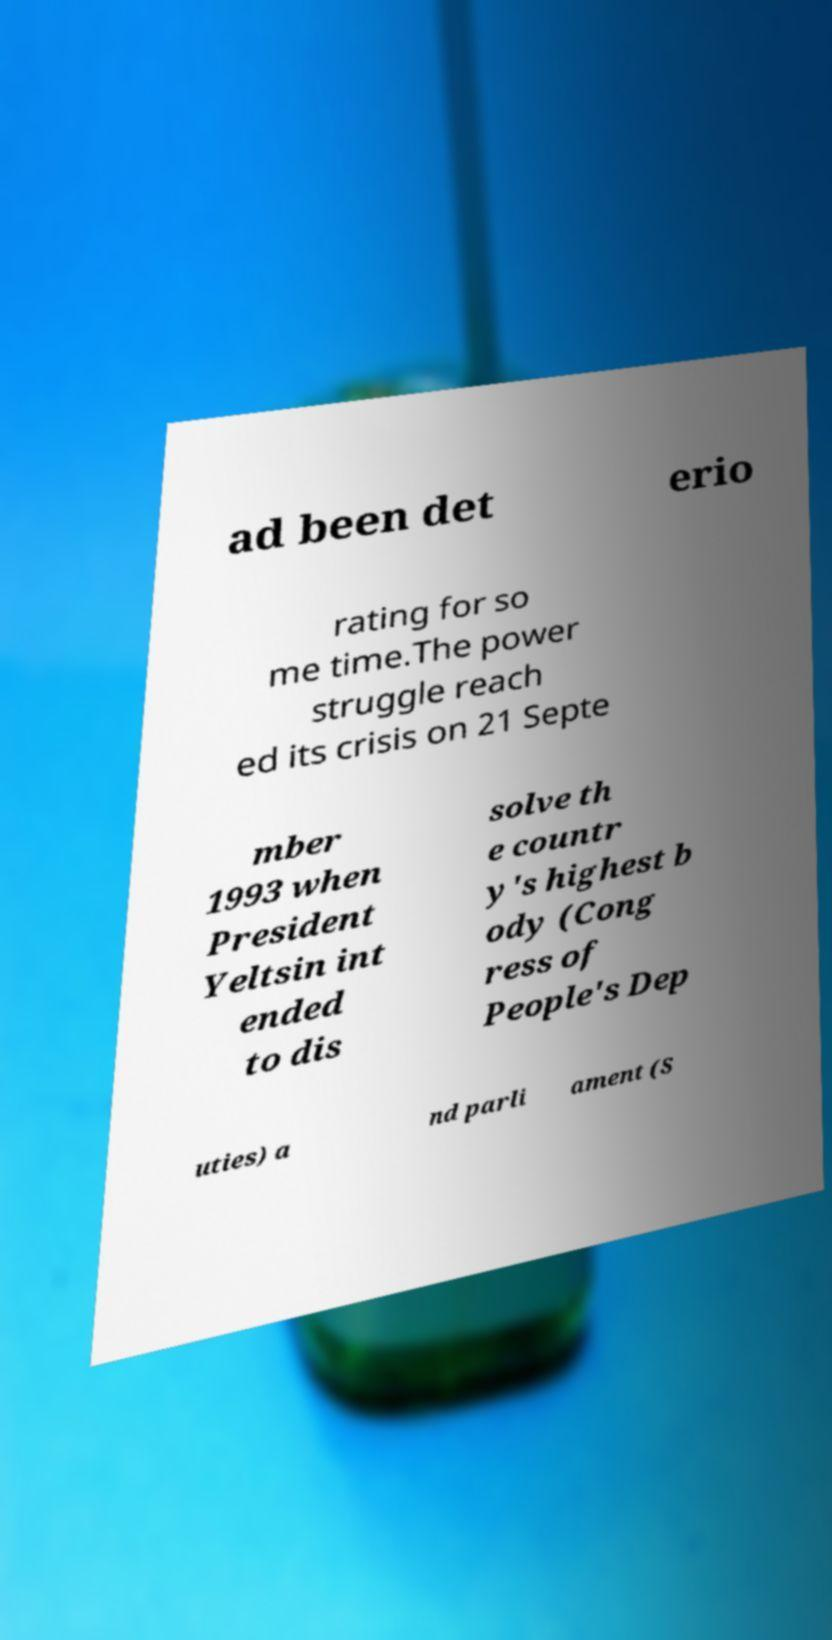There's text embedded in this image that I need extracted. Can you transcribe it verbatim? ad been det erio rating for so me time.The power struggle reach ed its crisis on 21 Septe mber 1993 when President Yeltsin int ended to dis solve th e countr y's highest b ody (Cong ress of People's Dep uties) a nd parli ament (S 